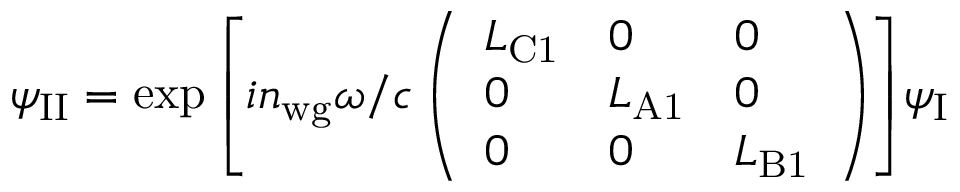Convert formula to latex. <formula><loc_0><loc_0><loc_500><loc_500>\psi _ { I I } = \exp { \left [ i n _ { w g } \omega / c \left ( \begin{array} { l l l } { L _ { C 1 } } & { 0 } & { 0 } \\ { 0 } & { L _ { A 1 } } & { 0 } \\ { 0 } & { 0 } & { L _ { B 1 } } \end{array} \right ) \right ] } \psi _ { I }</formula> 